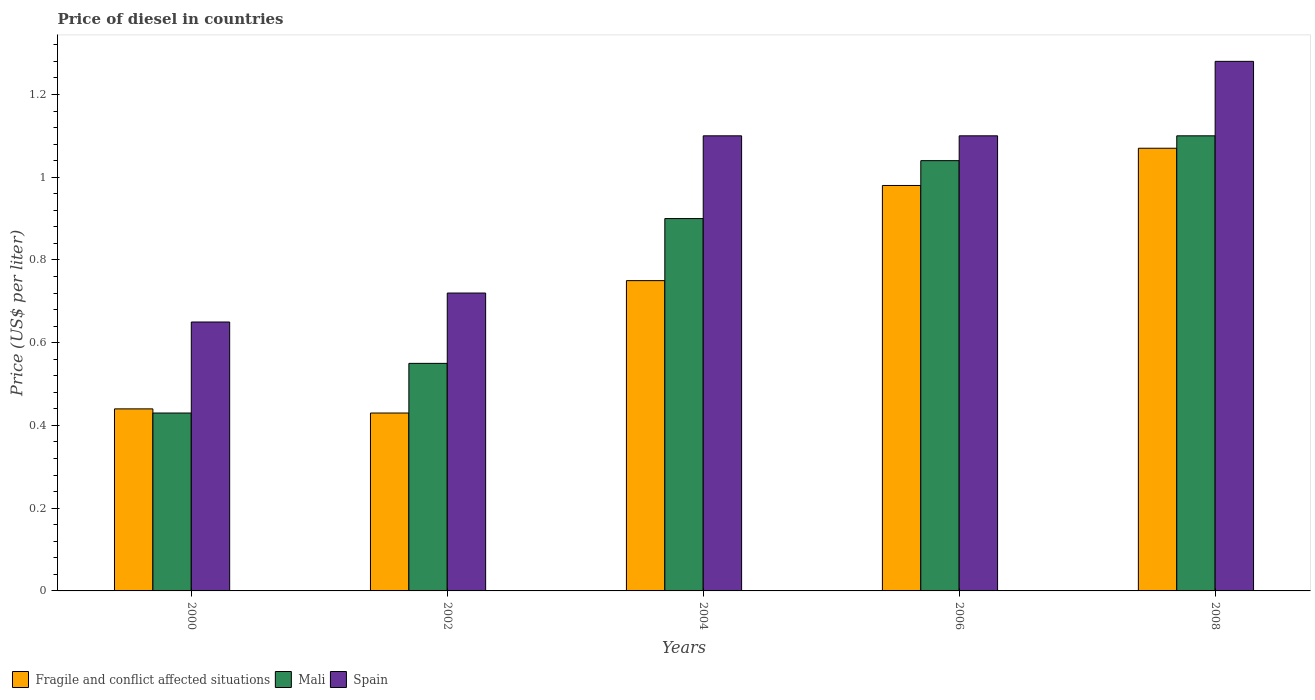How many different coloured bars are there?
Ensure brevity in your answer.  3. Are the number of bars per tick equal to the number of legend labels?
Keep it short and to the point. Yes. How many bars are there on the 3rd tick from the right?
Keep it short and to the point. 3. What is the label of the 2nd group of bars from the left?
Give a very brief answer. 2002. Across all years, what is the maximum price of diesel in Fragile and conflict affected situations?
Keep it short and to the point. 1.07. Across all years, what is the minimum price of diesel in Mali?
Make the answer very short. 0.43. In which year was the price of diesel in Spain minimum?
Give a very brief answer. 2000. What is the total price of diesel in Mali in the graph?
Provide a succinct answer. 4.02. What is the difference between the price of diesel in Fragile and conflict affected situations in 2002 and that in 2006?
Give a very brief answer. -0.55. What is the difference between the price of diesel in Spain in 2008 and the price of diesel in Mali in 2002?
Give a very brief answer. 0.73. What is the average price of diesel in Spain per year?
Ensure brevity in your answer.  0.97. In the year 2006, what is the difference between the price of diesel in Fragile and conflict affected situations and price of diesel in Mali?
Provide a succinct answer. -0.06. What is the ratio of the price of diesel in Mali in 2000 to that in 2006?
Offer a terse response. 0.41. Is the price of diesel in Mali in 2000 less than that in 2008?
Give a very brief answer. Yes. What is the difference between the highest and the second highest price of diesel in Mali?
Offer a terse response. 0.06. What is the difference between the highest and the lowest price of diesel in Mali?
Your answer should be compact. 0.67. In how many years, is the price of diesel in Spain greater than the average price of diesel in Spain taken over all years?
Give a very brief answer. 3. What does the 1st bar from the left in 2008 represents?
Provide a succinct answer. Fragile and conflict affected situations. What does the 2nd bar from the right in 2002 represents?
Ensure brevity in your answer.  Mali. How many bars are there?
Give a very brief answer. 15. Are all the bars in the graph horizontal?
Your answer should be compact. No. How many years are there in the graph?
Your response must be concise. 5. What is the difference between two consecutive major ticks on the Y-axis?
Make the answer very short. 0.2. Does the graph contain grids?
Your answer should be compact. No. What is the title of the graph?
Offer a terse response. Price of diesel in countries. What is the label or title of the X-axis?
Offer a terse response. Years. What is the label or title of the Y-axis?
Give a very brief answer. Price (US$ per liter). What is the Price (US$ per liter) of Fragile and conflict affected situations in 2000?
Offer a terse response. 0.44. What is the Price (US$ per liter) of Mali in 2000?
Your answer should be compact. 0.43. What is the Price (US$ per liter) in Spain in 2000?
Ensure brevity in your answer.  0.65. What is the Price (US$ per liter) of Fragile and conflict affected situations in 2002?
Offer a terse response. 0.43. What is the Price (US$ per liter) in Mali in 2002?
Make the answer very short. 0.55. What is the Price (US$ per liter) in Spain in 2002?
Provide a succinct answer. 0.72. What is the Price (US$ per liter) of Fragile and conflict affected situations in 2004?
Ensure brevity in your answer.  0.75. What is the Price (US$ per liter) of Mali in 2004?
Your answer should be very brief. 0.9. What is the Price (US$ per liter) of Spain in 2004?
Your response must be concise. 1.1. What is the Price (US$ per liter) in Fragile and conflict affected situations in 2006?
Provide a succinct answer. 0.98. What is the Price (US$ per liter) in Fragile and conflict affected situations in 2008?
Offer a terse response. 1.07. What is the Price (US$ per liter) of Spain in 2008?
Your answer should be very brief. 1.28. Across all years, what is the maximum Price (US$ per liter) in Fragile and conflict affected situations?
Provide a short and direct response. 1.07. Across all years, what is the maximum Price (US$ per liter) of Mali?
Keep it short and to the point. 1.1. Across all years, what is the maximum Price (US$ per liter) in Spain?
Keep it short and to the point. 1.28. Across all years, what is the minimum Price (US$ per liter) of Fragile and conflict affected situations?
Your response must be concise. 0.43. Across all years, what is the minimum Price (US$ per liter) in Mali?
Ensure brevity in your answer.  0.43. Across all years, what is the minimum Price (US$ per liter) of Spain?
Keep it short and to the point. 0.65. What is the total Price (US$ per liter) in Fragile and conflict affected situations in the graph?
Provide a succinct answer. 3.67. What is the total Price (US$ per liter) in Mali in the graph?
Give a very brief answer. 4.02. What is the total Price (US$ per liter) in Spain in the graph?
Your answer should be compact. 4.85. What is the difference between the Price (US$ per liter) of Mali in 2000 and that in 2002?
Your response must be concise. -0.12. What is the difference between the Price (US$ per liter) of Spain in 2000 and that in 2002?
Give a very brief answer. -0.07. What is the difference between the Price (US$ per liter) of Fragile and conflict affected situations in 2000 and that in 2004?
Your response must be concise. -0.31. What is the difference between the Price (US$ per liter) of Mali in 2000 and that in 2004?
Ensure brevity in your answer.  -0.47. What is the difference between the Price (US$ per liter) in Spain in 2000 and that in 2004?
Provide a short and direct response. -0.45. What is the difference between the Price (US$ per liter) of Fragile and conflict affected situations in 2000 and that in 2006?
Make the answer very short. -0.54. What is the difference between the Price (US$ per liter) in Mali in 2000 and that in 2006?
Make the answer very short. -0.61. What is the difference between the Price (US$ per liter) in Spain in 2000 and that in 2006?
Provide a succinct answer. -0.45. What is the difference between the Price (US$ per liter) in Fragile and conflict affected situations in 2000 and that in 2008?
Keep it short and to the point. -0.63. What is the difference between the Price (US$ per liter) of Mali in 2000 and that in 2008?
Your answer should be very brief. -0.67. What is the difference between the Price (US$ per liter) of Spain in 2000 and that in 2008?
Your answer should be compact. -0.63. What is the difference between the Price (US$ per liter) in Fragile and conflict affected situations in 2002 and that in 2004?
Provide a succinct answer. -0.32. What is the difference between the Price (US$ per liter) of Mali in 2002 and that in 2004?
Your response must be concise. -0.35. What is the difference between the Price (US$ per liter) of Spain in 2002 and that in 2004?
Make the answer very short. -0.38. What is the difference between the Price (US$ per liter) of Fragile and conflict affected situations in 2002 and that in 2006?
Provide a succinct answer. -0.55. What is the difference between the Price (US$ per liter) of Mali in 2002 and that in 2006?
Your answer should be compact. -0.49. What is the difference between the Price (US$ per liter) of Spain in 2002 and that in 2006?
Ensure brevity in your answer.  -0.38. What is the difference between the Price (US$ per liter) in Fragile and conflict affected situations in 2002 and that in 2008?
Your answer should be compact. -0.64. What is the difference between the Price (US$ per liter) in Mali in 2002 and that in 2008?
Your answer should be compact. -0.55. What is the difference between the Price (US$ per liter) of Spain in 2002 and that in 2008?
Provide a succinct answer. -0.56. What is the difference between the Price (US$ per liter) in Fragile and conflict affected situations in 2004 and that in 2006?
Ensure brevity in your answer.  -0.23. What is the difference between the Price (US$ per liter) in Mali in 2004 and that in 2006?
Provide a succinct answer. -0.14. What is the difference between the Price (US$ per liter) in Fragile and conflict affected situations in 2004 and that in 2008?
Offer a terse response. -0.32. What is the difference between the Price (US$ per liter) in Mali in 2004 and that in 2008?
Keep it short and to the point. -0.2. What is the difference between the Price (US$ per liter) of Spain in 2004 and that in 2008?
Your answer should be compact. -0.18. What is the difference between the Price (US$ per liter) in Fragile and conflict affected situations in 2006 and that in 2008?
Offer a very short reply. -0.09. What is the difference between the Price (US$ per liter) of Mali in 2006 and that in 2008?
Offer a terse response. -0.06. What is the difference between the Price (US$ per liter) in Spain in 2006 and that in 2008?
Give a very brief answer. -0.18. What is the difference between the Price (US$ per liter) of Fragile and conflict affected situations in 2000 and the Price (US$ per liter) of Mali in 2002?
Your answer should be compact. -0.11. What is the difference between the Price (US$ per liter) of Fragile and conflict affected situations in 2000 and the Price (US$ per liter) of Spain in 2002?
Keep it short and to the point. -0.28. What is the difference between the Price (US$ per liter) in Mali in 2000 and the Price (US$ per liter) in Spain in 2002?
Give a very brief answer. -0.29. What is the difference between the Price (US$ per liter) of Fragile and conflict affected situations in 2000 and the Price (US$ per liter) of Mali in 2004?
Provide a succinct answer. -0.46. What is the difference between the Price (US$ per liter) in Fragile and conflict affected situations in 2000 and the Price (US$ per liter) in Spain in 2004?
Provide a short and direct response. -0.66. What is the difference between the Price (US$ per liter) of Mali in 2000 and the Price (US$ per liter) of Spain in 2004?
Your answer should be very brief. -0.67. What is the difference between the Price (US$ per liter) in Fragile and conflict affected situations in 2000 and the Price (US$ per liter) in Mali in 2006?
Ensure brevity in your answer.  -0.6. What is the difference between the Price (US$ per liter) in Fragile and conflict affected situations in 2000 and the Price (US$ per liter) in Spain in 2006?
Provide a succinct answer. -0.66. What is the difference between the Price (US$ per liter) of Mali in 2000 and the Price (US$ per liter) of Spain in 2006?
Keep it short and to the point. -0.67. What is the difference between the Price (US$ per liter) in Fragile and conflict affected situations in 2000 and the Price (US$ per liter) in Mali in 2008?
Your response must be concise. -0.66. What is the difference between the Price (US$ per liter) in Fragile and conflict affected situations in 2000 and the Price (US$ per liter) in Spain in 2008?
Ensure brevity in your answer.  -0.84. What is the difference between the Price (US$ per liter) of Mali in 2000 and the Price (US$ per liter) of Spain in 2008?
Your answer should be compact. -0.85. What is the difference between the Price (US$ per liter) of Fragile and conflict affected situations in 2002 and the Price (US$ per liter) of Mali in 2004?
Provide a short and direct response. -0.47. What is the difference between the Price (US$ per liter) in Fragile and conflict affected situations in 2002 and the Price (US$ per liter) in Spain in 2004?
Offer a very short reply. -0.67. What is the difference between the Price (US$ per liter) of Mali in 2002 and the Price (US$ per liter) of Spain in 2004?
Offer a terse response. -0.55. What is the difference between the Price (US$ per liter) in Fragile and conflict affected situations in 2002 and the Price (US$ per liter) in Mali in 2006?
Offer a very short reply. -0.61. What is the difference between the Price (US$ per liter) in Fragile and conflict affected situations in 2002 and the Price (US$ per liter) in Spain in 2006?
Your answer should be very brief. -0.67. What is the difference between the Price (US$ per liter) of Mali in 2002 and the Price (US$ per liter) of Spain in 2006?
Your response must be concise. -0.55. What is the difference between the Price (US$ per liter) in Fragile and conflict affected situations in 2002 and the Price (US$ per liter) in Mali in 2008?
Offer a terse response. -0.67. What is the difference between the Price (US$ per liter) of Fragile and conflict affected situations in 2002 and the Price (US$ per liter) of Spain in 2008?
Provide a short and direct response. -0.85. What is the difference between the Price (US$ per liter) in Mali in 2002 and the Price (US$ per liter) in Spain in 2008?
Your response must be concise. -0.73. What is the difference between the Price (US$ per liter) of Fragile and conflict affected situations in 2004 and the Price (US$ per liter) of Mali in 2006?
Your answer should be compact. -0.29. What is the difference between the Price (US$ per liter) in Fragile and conflict affected situations in 2004 and the Price (US$ per liter) in Spain in 2006?
Your answer should be compact. -0.35. What is the difference between the Price (US$ per liter) of Mali in 2004 and the Price (US$ per liter) of Spain in 2006?
Offer a terse response. -0.2. What is the difference between the Price (US$ per liter) of Fragile and conflict affected situations in 2004 and the Price (US$ per liter) of Mali in 2008?
Your answer should be very brief. -0.35. What is the difference between the Price (US$ per liter) in Fragile and conflict affected situations in 2004 and the Price (US$ per liter) in Spain in 2008?
Keep it short and to the point. -0.53. What is the difference between the Price (US$ per liter) of Mali in 2004 and the Price (US$ per liter) of Spain in 2008?
Make the answer very short. -0.38. What is the difference between the Price (US$ per liter) in Fragile and conflict affected situations in 2006 and the Price (US$ per liter) in Mali in 2008?
Ensure brevity in your answer.  -0.12. What is the difference between the Price (US$ per liter) of Fragile and conflict affected situations in 2006 and the Price (US$ per liter) of Spain in 2008?
Make the answer very short. -0.3. What is the difference between the Price (US$ per liter) in Mali in 2006 and the Price (US$ per liter) in Spain in 2008?
Ensure brevity in your answer.  -0.24. What is the average Price (US$ per liter) in Fragile and conflict affected situations per year?
Keep it short and to the point. 0.73. What is the average Price (US$ per liter) of Mali per year?
Your answer should be compact. 0.8. In the year 2000, what is the difference between the Price (US$ per liter) in Fragile and conflict affected situations and Price (US$ per liter) in Spain?
Make the answer very short. -0.21. In the year 2000, what is the difference between the Price (US$ per liter) of Mali and Price (US$ per liter) of Spain?
Give a very brief answer. -0.22. In the year 2002, what is the difference between the Price (US$ per liter) of Fragile and conflict affected situations and Price (US$ per liter) of Mali?
Give a very brief answer. -0.12. In the year 2002, what is the difference between the Price (US$ per liter) of Fragile and conflict affected situations and Price (US$ per liter) of Spain?
Your response must be concise. -0.29. In the year 2002, what is the difference between the Price (US$ per liter) in Mali and Price (US$ per liter) in Spain?
Provide a short and direct response. -0.17. In the year 2004, what is the difference between the Price (US$ per liter) in Fragile and conflict affected situations and Price (US$ per liter) in Spain?
Your answer should be compact. -0.35. In the year 2004, what is the difference between the Price (US$ per liter) of Mali and Price (US$ per liter) of Spain?
Offer a terse response. -0.2. In the year 2006, what is the difference between the Price (US$ per liter) of Fragile and conflict affected situations and Price (US$ per liter) of Mali?
Provide a short and direct response. -0.06. In the year 2006, what is the difference between the Price (US$ per liter) of Fragile and conflict affected situations and Price (US$ per liter) of Spain?
Make the answer very short. -0.12. In the year 2006, what is the difference between the Price (US$ per liter) in Mali and Price (US$ per liter) in Spain?
Offer a terse response. -0.06. In the year 2008, what is the difference between the Price (US$ per liter) of Fragile and conflict affected situations and Price (US$ per liter) of Mali?
Give a very brief answer. -0.03. In the year 2008, what is the difference between the Price (US$ per liter) in Fragile and conflict affected situations and Price (US$ per liter) in Spain?
Give a very brief answer. -0.21. In the year 2008, what is the difference between the Price (US$ per liter) of Mali and Price (US$ per liter) of Spain?
Offer a terse response. -0.18. What is the ratio of the Price (US$ per liter) in Fragile and conflict affected situations in 2000 to that in 2002?
Provide a short and direct response. 1.02. What is the ratio of the Price (US$ per liter) in Mali in 2000 to that in 2002?
Ensure brevity in your answer.  0.78. What is the ratio of the Price (US$ per liter) of Spain in 2000 to that in 2002?
Your answer should be compact. 0.9. What is the ratio of the Price (US$ per liter) of Fragile and conflict affected situations in 2000 to that in 2004?
Your answer should be very brief. 0.59. What is the ratio of the Price (US$ per liter) of Mali in 2000 to that in 2004?
Provide a short and direct response. 0.48. What is the ratio of the Price (US$ per liter) of Spain in 2000 to that in 2004?
Ensure brevity in your answer.  0.59. What is the ratio of the Price (US$ per liter) in Fragile and conflict affected situations in 2000 to that in 2006?
Provide a short and direct response. 0.45. What is the ratio of the Price (US$ per liter) in Mali in 2000 to that in 2006?
Provide a short and direct response. 0.41. What is the ratio of the Price (US$ per liter) in Spain in 2000 to that in 2006?
Offer a very short reply. 0.59. What is the ratio of the Price (US$ per liter) in Fragile and conflict affected situations in 2000 to that in 2008?
Provide a succinct answer. 0.41. What is the ratio of the Price (US$ per liter) in Mali in 2000 to that in 2008?
Provide a short and direct response. 0.39. What is the ratio of the Price (US$ per liter) in Spain in 2000 to that in 2008?
Your answer should be compact. 0.51. What is the ratio of the Price (US$ per liter) of Fragile and conflict affected situations in 2002 to that in 2004?
Keep it short and to the point. 0.57. What is the ratio of the Price (US$ per liter) of Mali in 2002 to that in 2004?
Your answer should be very brief. 0.61. What is the ratio of the Price (US$ per liter) of Spain in 2002 to that in 2004?
Provide a succinct answer. 0.65. What is the ratio of the Price (US$ per liter) in Fragile and conflict affected situations in 2002 to that in 2006?
Offer a very short reply. 0.44. What is the ratio of the Price (US$ per liter) in Mali in 2002 to that in 2006?
Keep it short and to the point. 0.53. What is the ratio of the Price (US$ per liter) of Spain in 2002 to that in 2006?
Offer a terse response. 0.65. What is the ratio of the Price (US$ per liter) in Fragile and conflict affected situations in 2002 to that in 2008?
Provide a short and direct response. 0.4. What is the ratio of the Price (US$ per liter) of Mali in 2002 to that in 2008?
Make the answer very short. 0.5. What is the ratio of the Price (US$ per liter) in Spain in 2002 to that in 2008?
Your answer should be compact. 0.56. What is the ratio of the Price (US$ per liter) in Fragile and conflict affected situations in 2004 to that in 2006?
Offer a very short reply. 0.77. What is the ratio of the Price (US$ per liter) in Mali in 2004 to that in 2006?
Your answer should be compact. 0.87. What is the ratio of the Price (US$ per liter) in Fragile and conflict affected situations in 2004 to that in 2008?
Provide a succinct answer. 0.7. What is the ratio of the Price (US$ per liter) in Mali in 2004 to that in 2008?
Make the answer very short. 0.82. What is the ratio of the Price (US$ per liter) in Spain in 2004 to that in 2008?
Give a very brief answer. 0.86. What is the ratio of the Price (US$ per liter) in Fragile and conflict affected situations in 2006 to that in 2008?
Offer a terse response. 0.92. What is the ratio of the Price (US$ per liter) in Mali in 2006 to that in 2008?
Provide a succinct answer. 0.95. What is the ratio of the Price (US$ per liter) of Spain in 2006 to that in 2008?
Your answer should be compact. 0.86. What is the difference between the highest and the second highest Price (US$ per liter) in Fragile and conflict affected situations?
Give a very brief answer. 0.09. What is the difference between the highest and the second highest Price (US$ per liter) of Spain?
Provide a short and direct response. 0.18. What is the difference between the highest and the lowest Price (US$ per liter) of Fragile and conflict affected situations?
Provide a succinct answer. 0.64. What is the difference between the highest and the lowest Price (US$ per liter) in Mali?
Offer a very short reply. 0.67. What is the difference between the highest and the lowest Price (US$ per liter) in Spain?
Provide a short and direct response. 0.63. 